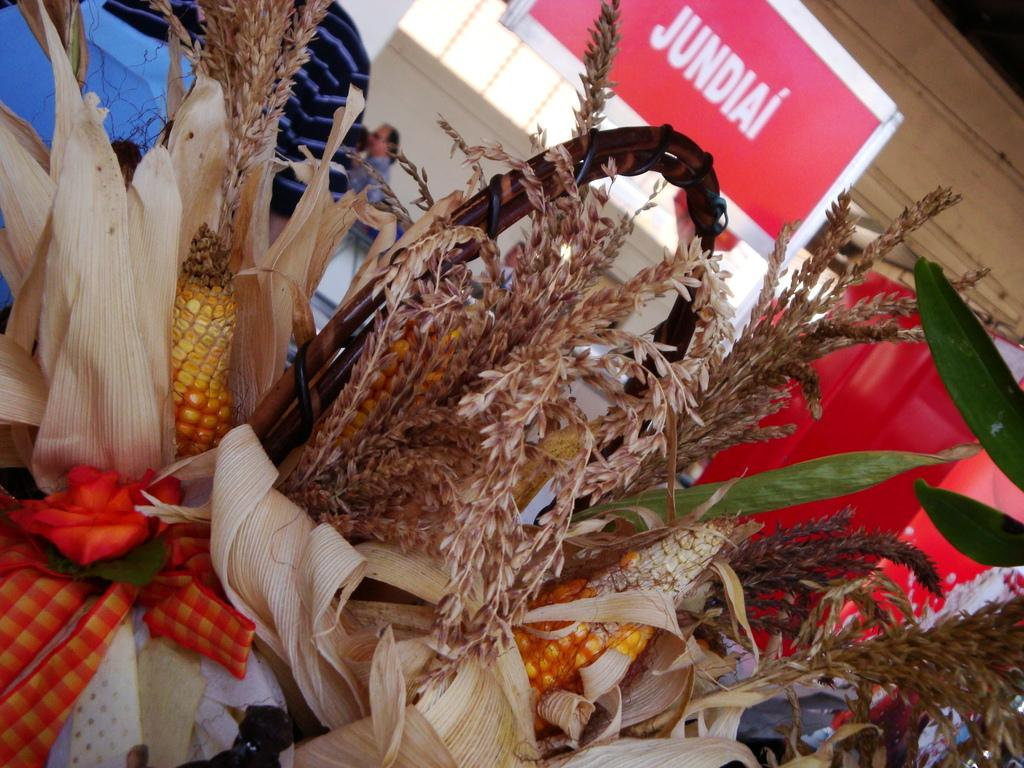What type of plants can be seen in the image? There are paddy plants and maize plants in the image. Are there any people visible in the image? Yes, there are two persons in the background of the image. What can be seen in the background besides the people? There is a wall in the background of the image, and on the wall, there is a board with text. What type of bone can be seen in the image? There is no bone present in the image. Can you describe the rat's behavior in the image? There is no rat present in the image. 